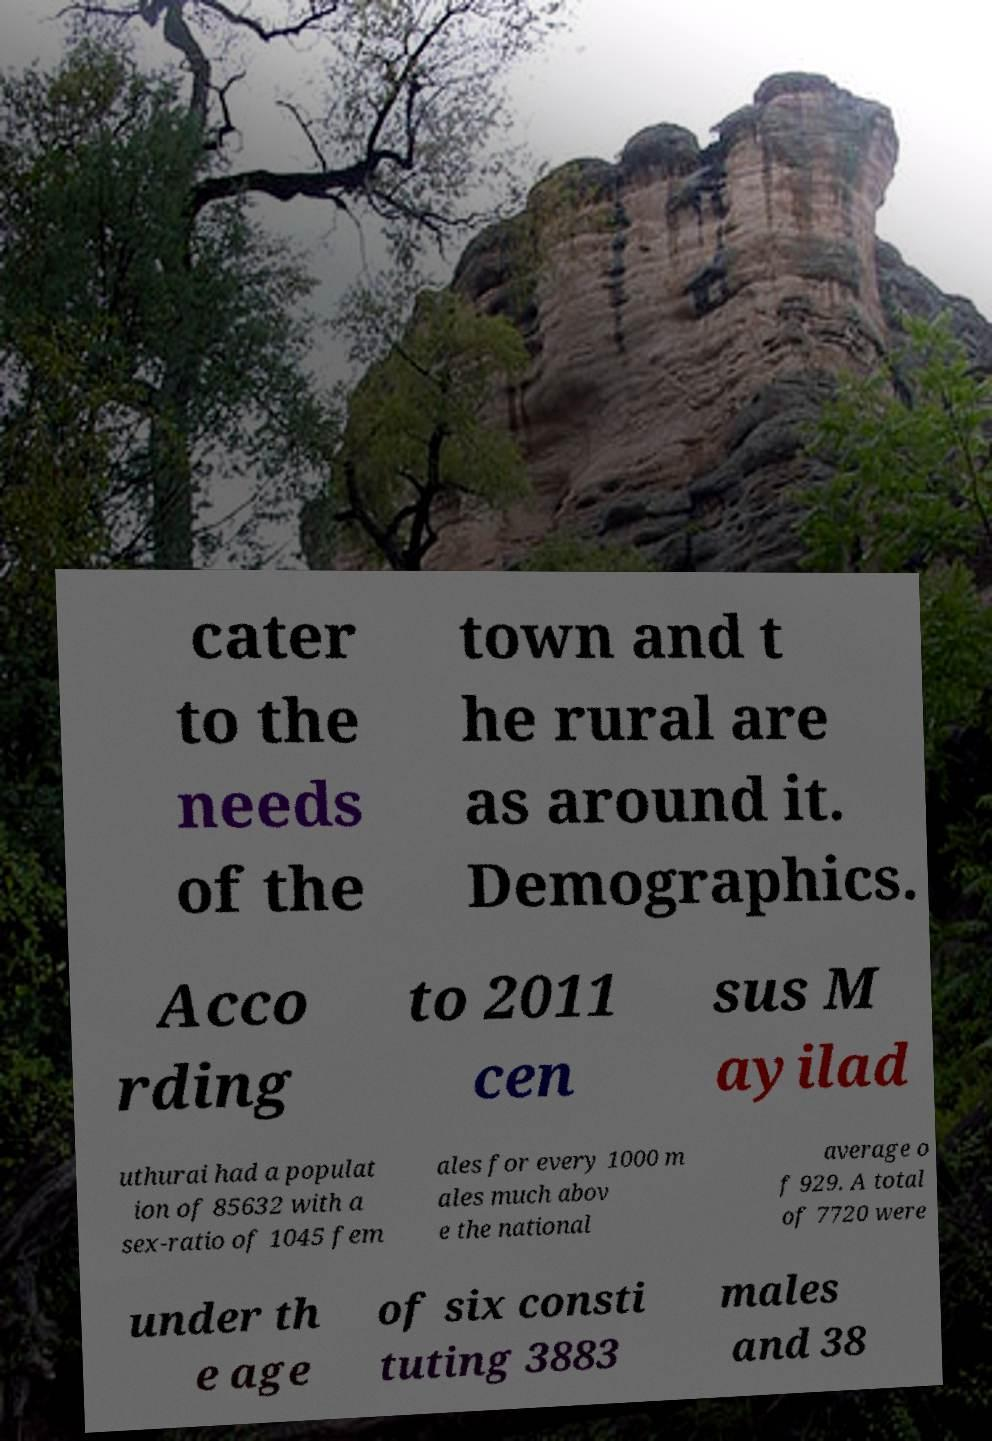Could you extract and type out the text from this image? cater to the needs of the town and t he rural are as around it. Demographics. Acco rding to 2011 cen sus M ayilad uthurai had a populat ion of 85632 with a sex-ratio of 1045 fem ales for every 1000 m ales much abov e the national average o f 929. A total of 7720 were under th e age of six consti tuting 3883 males and 38 